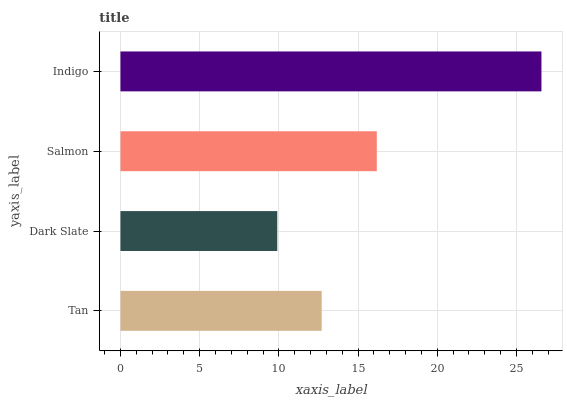Is Dark Slate the minimum?
Answer yes or no. Yes. Is Indigo the maximum?
Answer yes or no. Yes. Is Salmon the minimum?
Answer yes or no. No. Is Salmon the maximum?
Answer yes or no. No. Is Salmon greater than Dark Slate?
Answer yes or no. Yes. Is Dark Slate less than Salmon?
Answer yes or no. Yes. Is Dark Slate greater than Salmon?
Answer yes or no. No. Is Salmon less than Dark Slate?
Answer yes or no. No. Is Salmon the high median?
Answer yes or no. Yes. Is Tan the low median?
Answer yes or no. Yes. Is Tan the high median?
Answer yes or no. No. Is Indigo the low median?
Answer yes or no. No. 